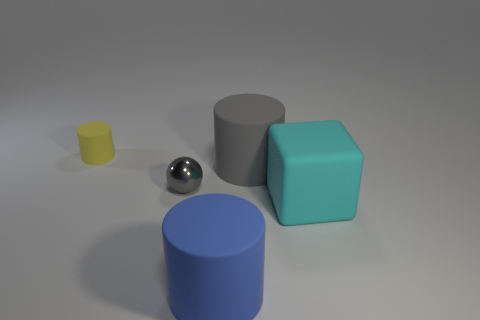Subtract all big rubber cylinders. How many cylinders are left? 1 Add 1 tiny gray balls. How many objects exist? 6 Subtract all blue cylinders. How many cylinders are left? 2 Subtract all balls. How many objects are left? 4 Subtract all red cylinders. Subtract all red spheres. How many cylinders are left? 3 Subtract all gray spheres. Subtract all small red cubes. How many objects are left? 4 Add 2 tiny shiny balls. How many tiny shiny balls are left? 3 Add 2 small gray matte cylinders. How many small gray matte cylinders exist? 2 Subtract 0 blue cubes. How many objects are left? 5 